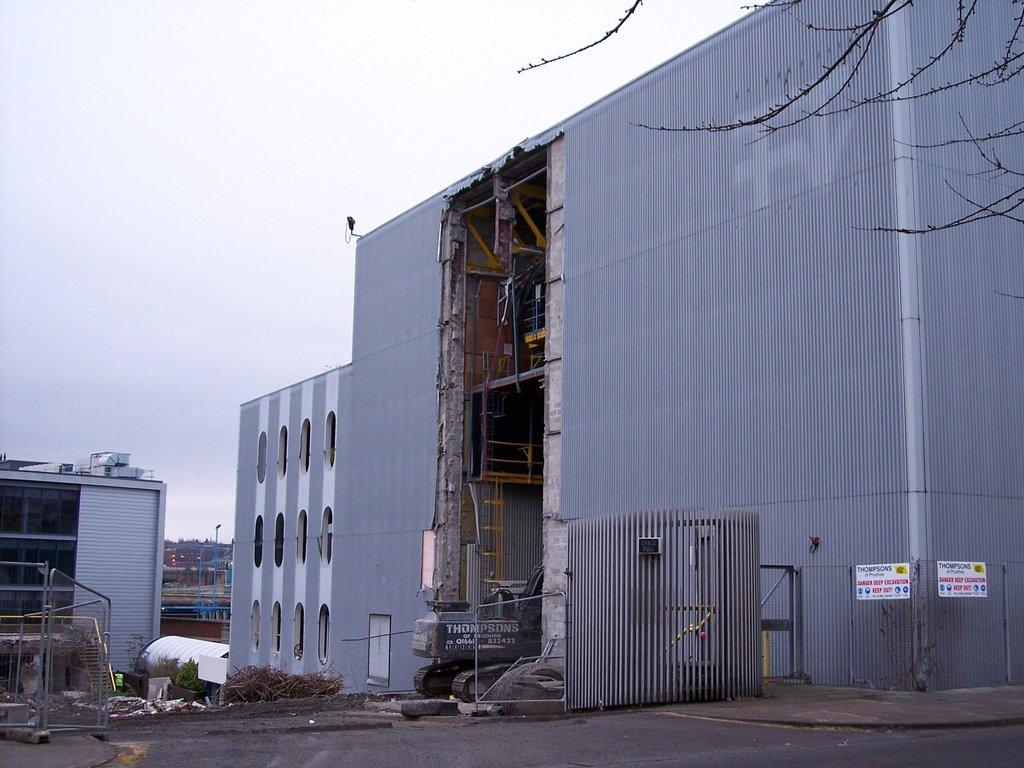What type of structures can be seen in the image? There are buildings in the image. What else is present in the image besides buildings? There are plants and other objects in the image. What can be seen in the background of the image? The sky is visible in the background of the image. What type of system is being used by the horse in the image? There is no horse present in the image, so it is not possible to determine what type of system might be used by a horse. 